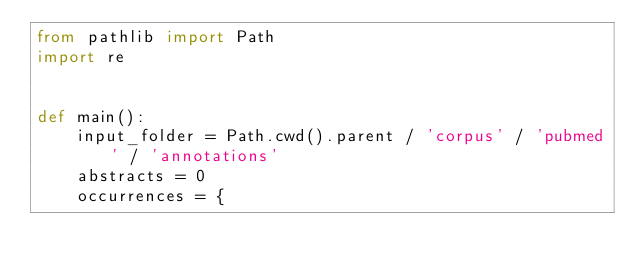<code> <loc_0><loc_0><loc_500><loc_500><_Python_>from pathlib import Path
import re


def main():
    input_folder = Path.cwd().parent / 'corpus' / 'pubmed' / 'annotations'
    abstracts = 0
    occurrences = {</code> 